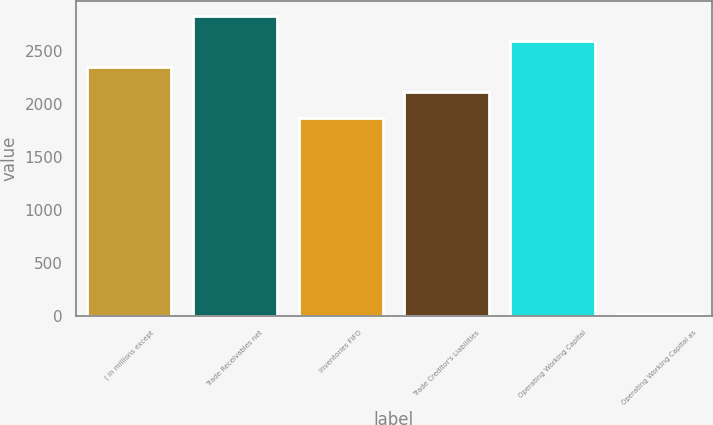Convert chart to OTSL. <chart><loc_0><loc_0><loc_500><loc_500><bar_chart><fcel>( in millions except<fcel>Trade Receivables net<fcel>Inventories FIFO<fcel>Trade Creditor's Liabilities<fcel>Operating Working Capital<fcel>Operating Working Capital as<nl><fcel>2347.44<fcel>2826.88<fcel>1868<fcel>2107.72<fcel>2587.16<fcel>15.8<nl></chart> 